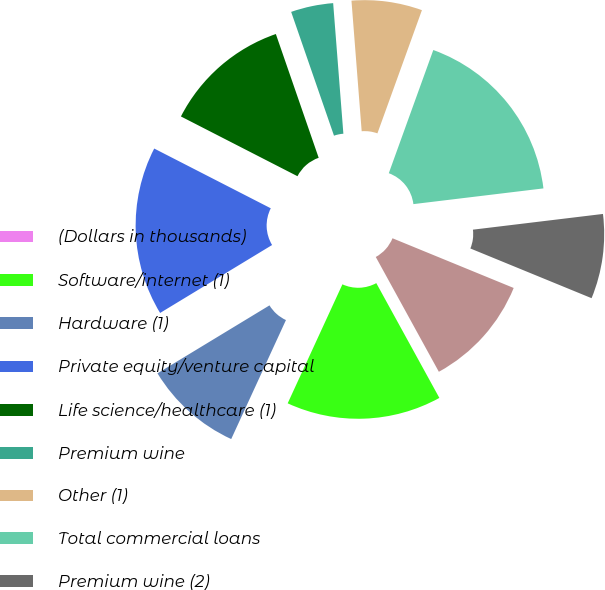Convert chart to OTSL. <chart><loc_0><loc_0><loc_500><loc_500><pie_chart><fcel>(Dollars in thousands)<fcel>Software/internet (1)<fcel>Hardware (1)<fcel>Private equity/venture capital<fcel>Life science/healthcare (1)<fcel>Premium wine<fcel>Other (1)<fcel>Total commercial loans<fcel>Premium wine (2)<fcel>Consumer loans (3)<nl><fcel>0.0%<fcel>14.86%<fcel>9.46%<fcel>16.22%<fcel>12.16%<fcel>4.06%<fcel>6.76%<fcel>17.57%<fcel>8.11%<fcel>10.81%<nl></chart> 